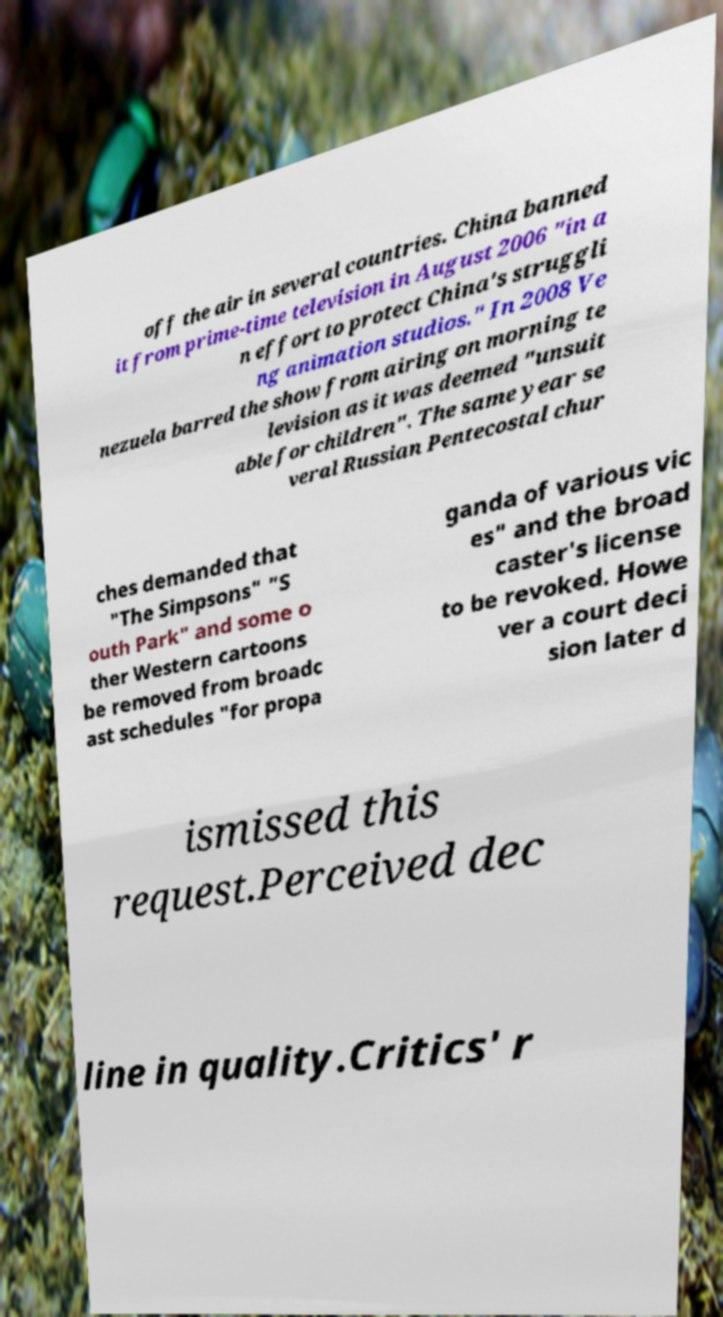What messages or text are displayed in this image? I need them in a readable, typed format. off the air in several countries. China banned it from prime-time television in August 2006 "in a n effort to protect China's struggli ng animation studios." In 2008 Ve nezuela barred the show from airing on morning te levision as it was deemed "unsuit able for children". The same year se veral Russian Pentecostal chur ches demanded that "The Simpsons" "S outh Park" and some o ther Western cartoons be removed from broadc ast schedules "for propa ganda of various vic es" and the broad caster's license to be revoked. Howe ver a court deci sion later d ismissed this request.Perceived dec line in quality.Critics' r 